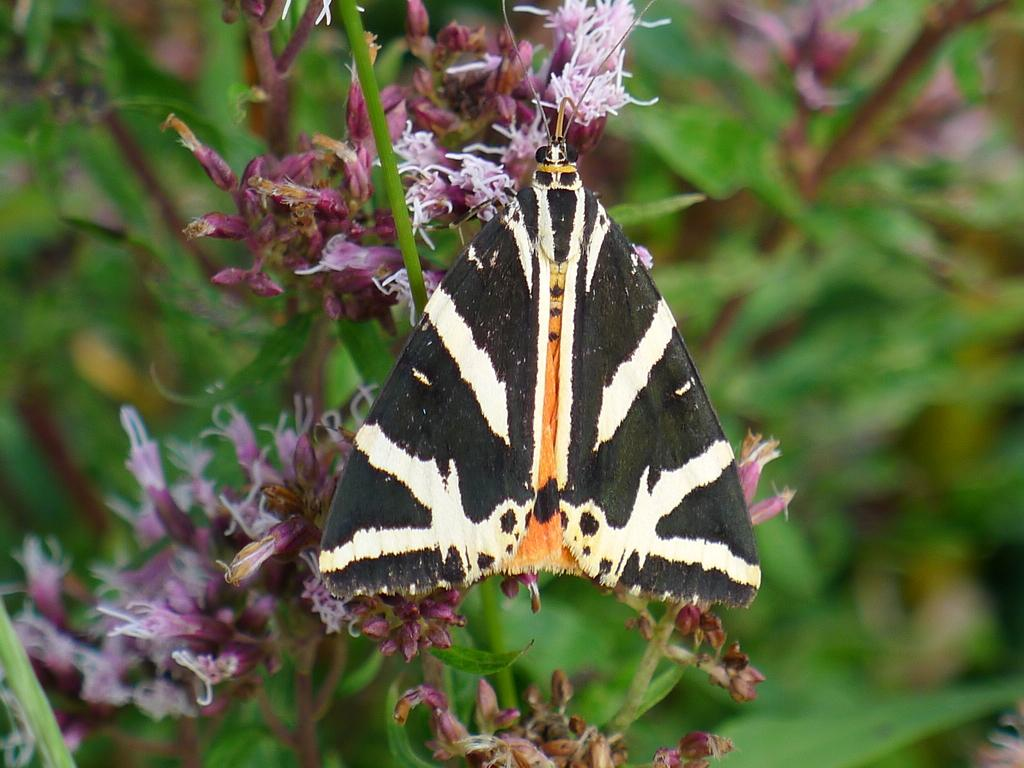What type of creature is present in the image? There is an insect in the image. Where is the insect located? The insect is on the flowers. Can you describe the background of the image? The background of the image is blurred. What action is the actor performing in the image? There is no actor or action present in the image; it features an insect on flowers with a blurred background. 